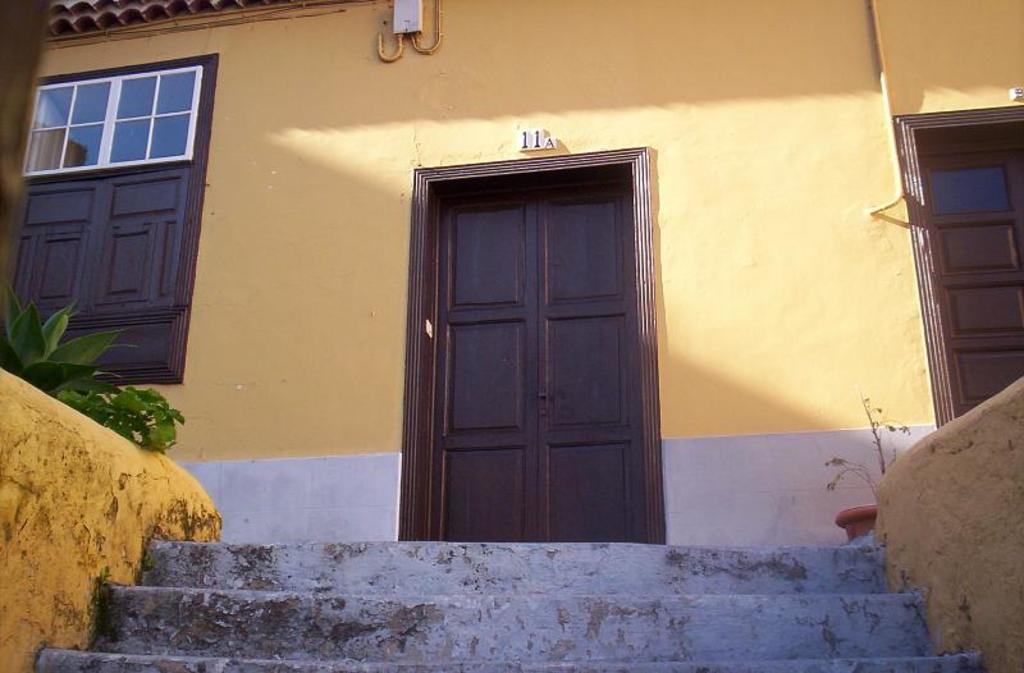What type of structure is present in the image? The image contains a building. What features can be observed on the building? The building has doors and windows. What architectural element is present in front of the building? There are steps in front of the building. What type of vegetation is present near the building? There are plants on the left side of the building. What object can be seen on the right side of the building? There is a pot on the right side of the building. What type of comb is used to groom the plants on the left side of the building? There is no comb present in the image, and the plants do not require grooming. 